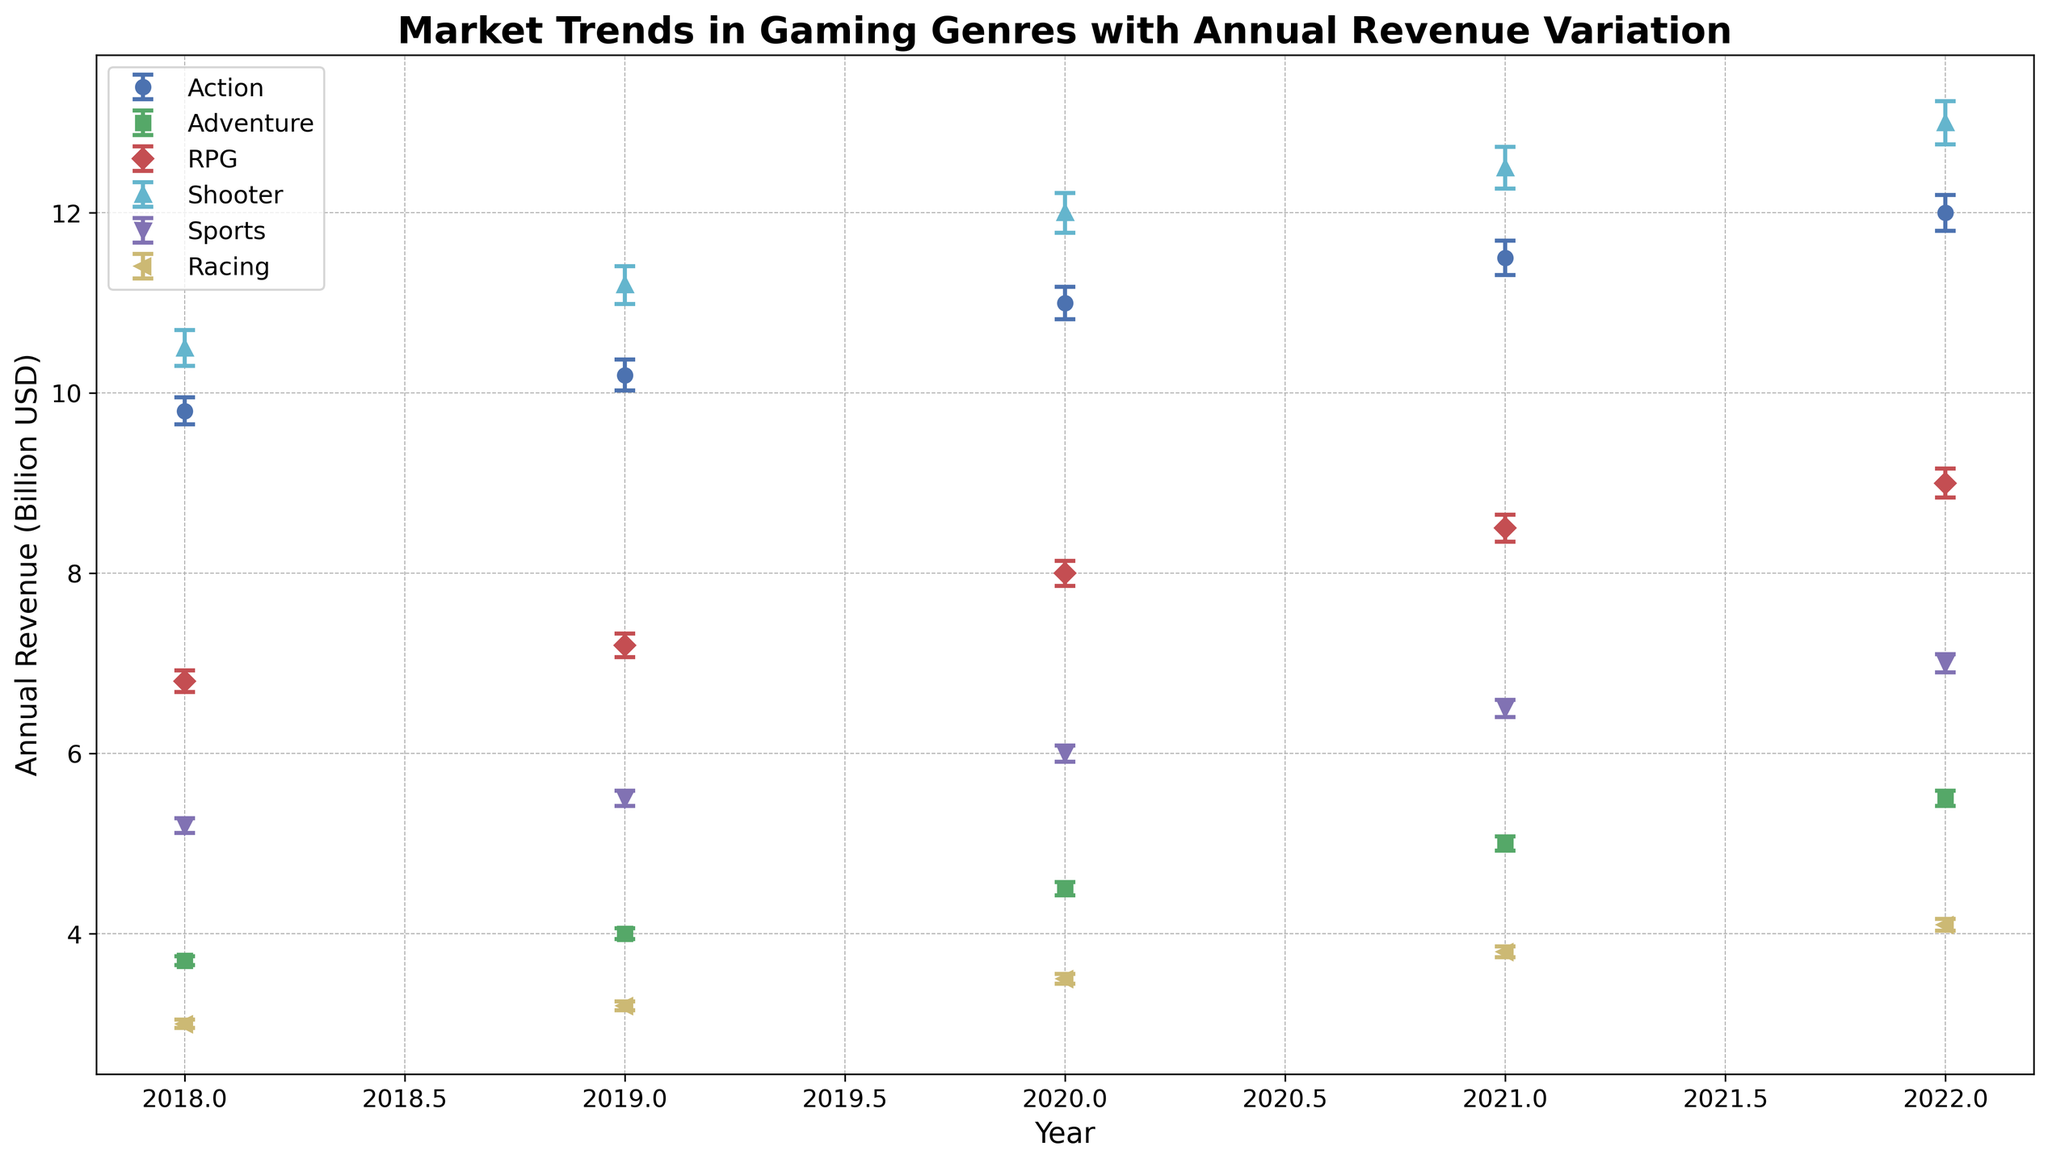Who has the highest annual revenue in 2022? According to the figure, find the genre with the highest point in 2022 and look at the label corresponding to that point. The highest annual revenue in 2022 is from the Shooter genre.
Answer: Shooter Which genre shows the largest increase in annual revenue from 2018 to 2022? To find this, we look at the change in the points for each genre between 2018 and 2022. Shooter started at approximately 10.5 billion USD in 2018 and increased to 13 billion USD in 2022, an increase of 2.5 billion USD. No other genre shows a larger increase.
Answer: Shooter What is the average annual revenue of the RPG genre over the years displayed? Adding up the annual revenues for RPG from 2018 to 2022 is 6.8 + 7.2 + 8 + 8.5 + 9 = 39.5 billion USD. Dividing by the 5 years gives an average annual revenue of 39.5/5 = 7.9 billion USD.
Answer: 7.9 billion USD Which genre has consistently increased its revenue every year from 2018 to 2022? By examining the plot lines, we note that the genres where the data points increase every year are Action, Adventure, RPG, Shooter, and Sports. But Racing shows an increase only in the last three years.
Answer: Action, Adventure, RPG, Shooter, Sports What is the revenue variation for the Adventure genre in 2020? Referring to the errorbars for Adventure in the year 2020, the revenue variation is approximately 75 million USD.
Answer: 75 million USD How does the revenue variation for Sports in 2021 compare to that in 2020? By comparing the size of the error bars for Sports in 2020 and 2021, we can see that the error bar length in 2021 (95 million USD) is larger than in 2020 (90 million USD).
Answer: Greater What is the total revenue for the Action genre across all years displayed? Summing the annual revenues for the Action genre from 2018 to 2022 yields 9.8 + 10.2 + 11 + 11.5 + 12 = 54.5 billion USD.
Answer: 54.5 billion USD Which genre had the largest revenue variation in any single year over the observed time period? By comparing all the error bars across all years, the largest revenue variation appears for the Shooter genre in 2022, with a variation of 240 million USD.
Answer: Shooter 